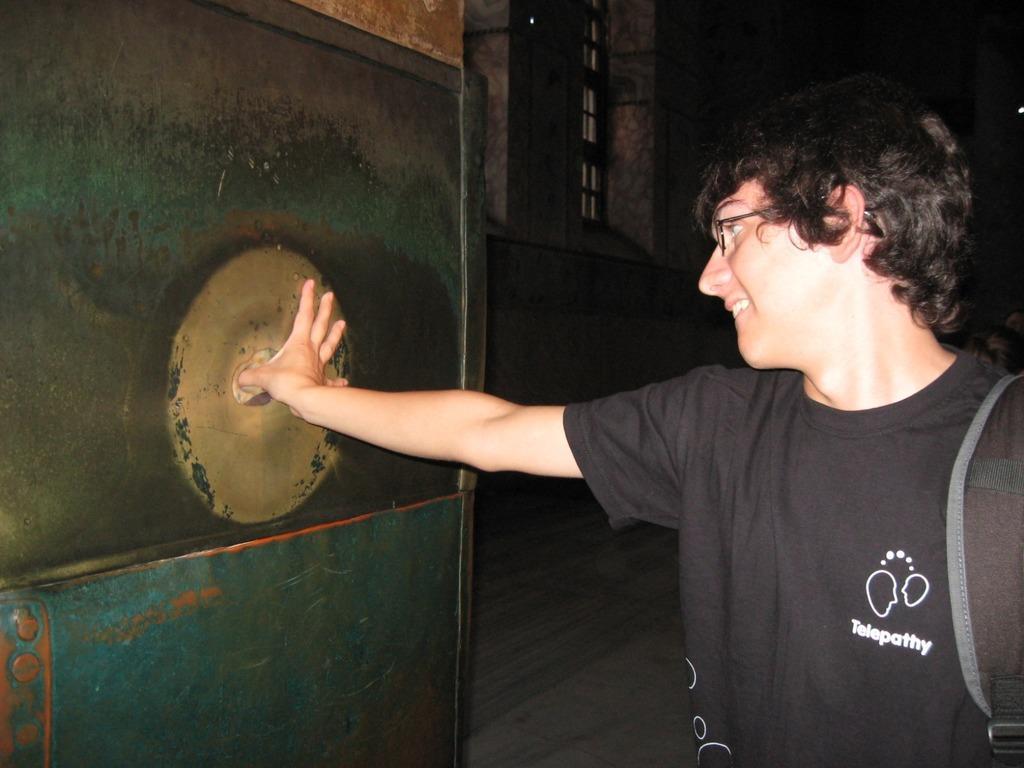In one or two sentences, can you explain what this image depicts? In this image, we can see a person wearing glasses and a bag and placing his hand on the door. In the background, there is a window and we can see a wall. At the bottom, there is floor. 